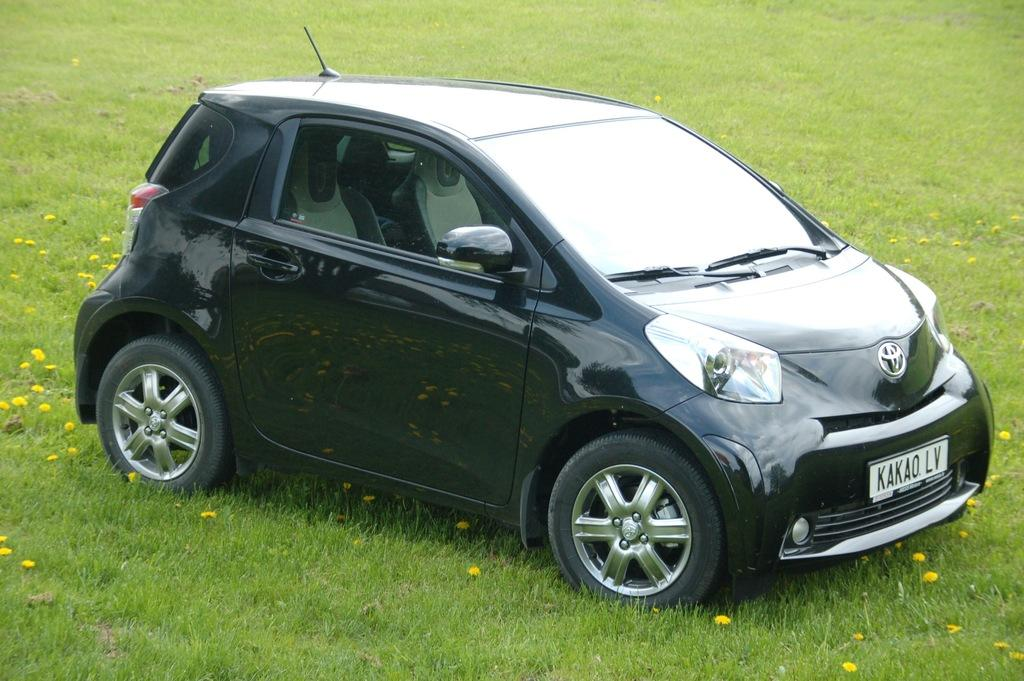What type of vegetation is present in the image? There is grass in the image. What is the main subject in the middle of the image? There is a car in the middle of the image. How many bike representatives can be seen in the image? There are no bike representatives or bikes present in the image. What color are the legs of the person in the car? There is no person visible in the car, and therefore no legs can be seen. 